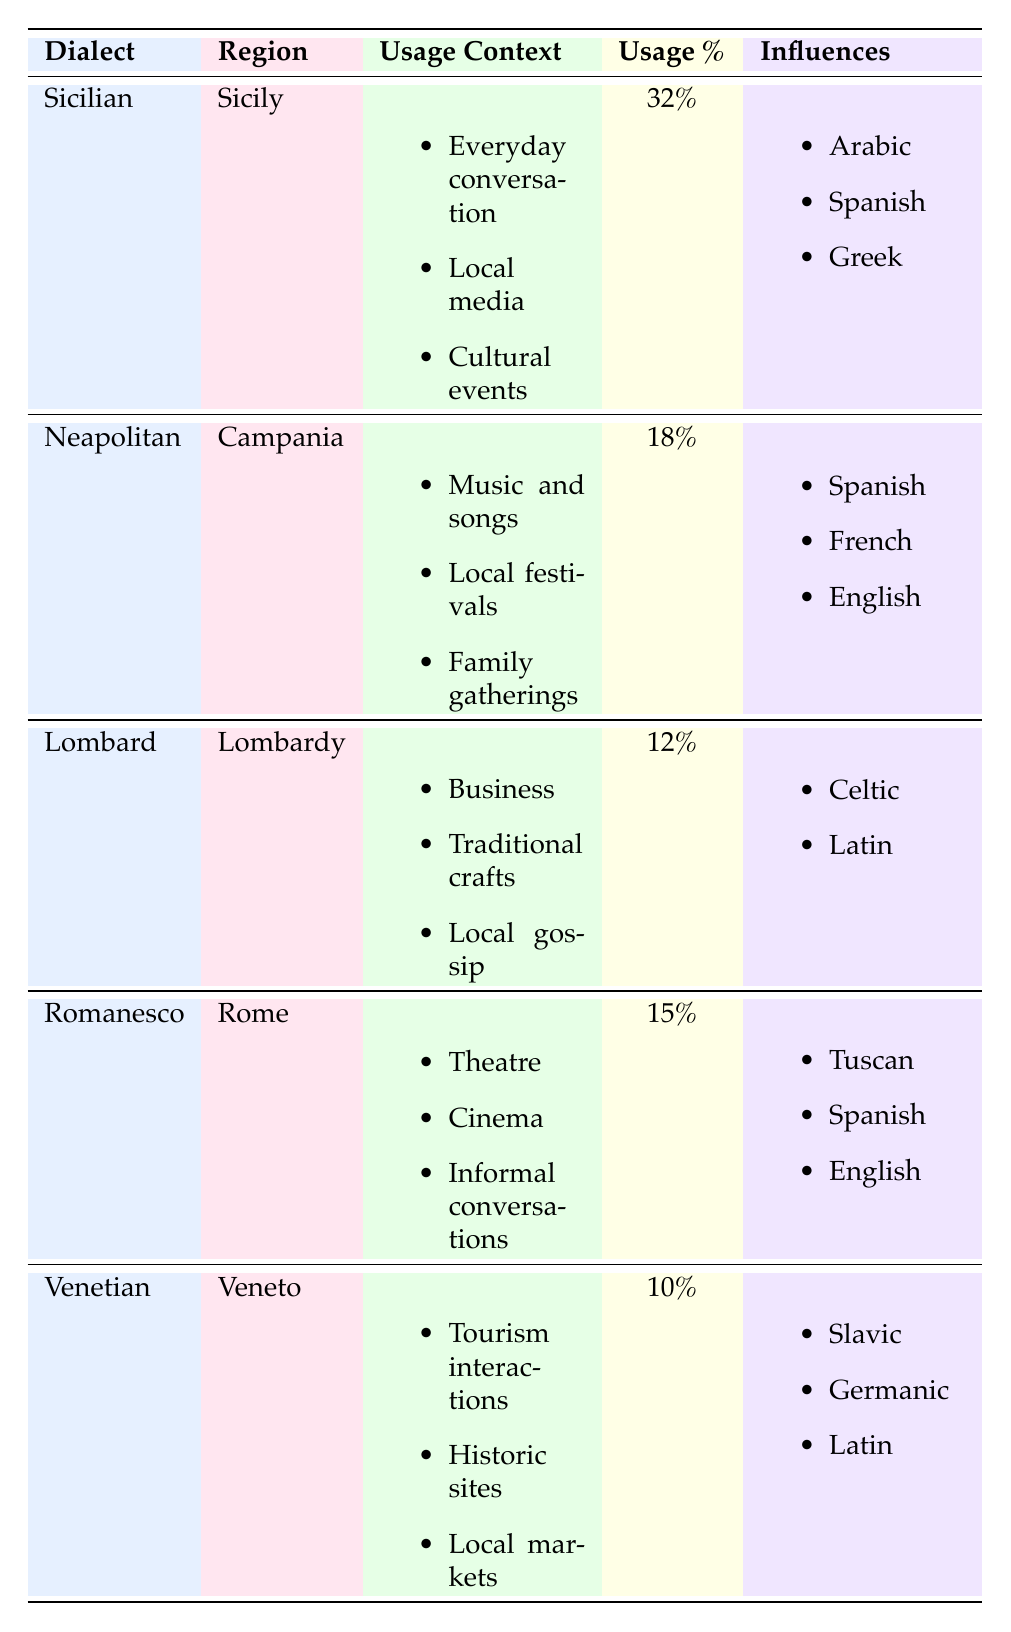What is the usage percentage of the Sicilian dialect? The table shows that the usage percentage for the Sicilian dialect is listed directly in the column under Usage %.
Answer: 32% Which dialect has the highest percentage of usage? By examining the Usage % column, we can see that Sicilian has the highest percentage at 32%.
Answer: Sicilian Is the Venetian dialect influenced by Greek? The table lists the influences for the Venetian dialect, and Greek is not mentioned among them. Therefore, it is false that Venetian is influenced by Greek.
Answer: No What is the total usage percentage of the top three dialects in the table? The usage percentages of the top three dialects are Sicilian (32%), Neapolitan (18%), and Romanesco (15%). Adding these gives us 32 + 18 + 15 = 65%.
Answer: 65% Which region has a dialect with influences from Slavic languages? The table shows that the Venetian dialect is influenced by Slavic, and it is spoken in the Veneto region.
Answer: Veneto Does the Neapolitan dialect have a significant cultural context in music and songs? The usage context for the Neapolitan dialect clearly includes "Music and songs," confirming its significant cultural context in that area.
Answer: Yes In which regions are the Lombard and Romanesco dialects spoken? Lombard is spoken in Lombardy, and Romanesco is spoken in Rome. These regions are specified directly in the table under the Region column.
Answer: Lombardy and Rome What is the average usage percentage of all dialects listed in the table? To find the average, add all the usage percentages: 32 + 18 + 12 + 15 + 10 = 87. Then divide by the total number of dialects (5): 87 / 5 = 17.4.
Answer: 17.4 Which dialect primarily relates to everyday conversation and local media? The table indicates that Sicilian is used in contexts of "Everyday conversation" and "Local media," making it the answer to this question.
Answer: Sicilian 